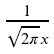Convert formula to latex. <formula><loc_0><loc_0><loc_500><loc_500>\frac { 1 } { \sqrt { 2 \pi } x }</formula> 